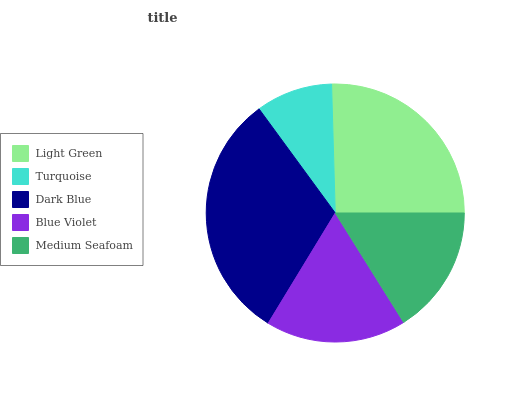Is Turquoise the minimum?
Answer yes or no. Yes. Is Dark Blue the maximum?
Answer yes or no. Yes. Is Dark Blue the minimum?
Answer yes or no. No. Is Turquoise the maximum?
Answer yes or no. No. Is Dark Blue greater than Turquoise?
Answer yes or no. Yes. Is Turquoise less than Dark Blue?
Answer yes or no. Yes. Is Turquoise greater than Dark Blue?
Answer yes or no. No. Is Dark Blue less than Turquoise?
Answer yes or no. No. Is Blue Violet the high median?
Answer yes or no. Yes. Is Blue Violet the low median?
Answer yes or no. Yes. Is Light Green the high median?
Answer yes or no. No. Is Turquoise the low median?
Answer yes or no. No. 